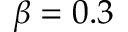<formula> <loc_0><loc_0><loc_500><loc_500>\beta = 0 . 3</formula> 